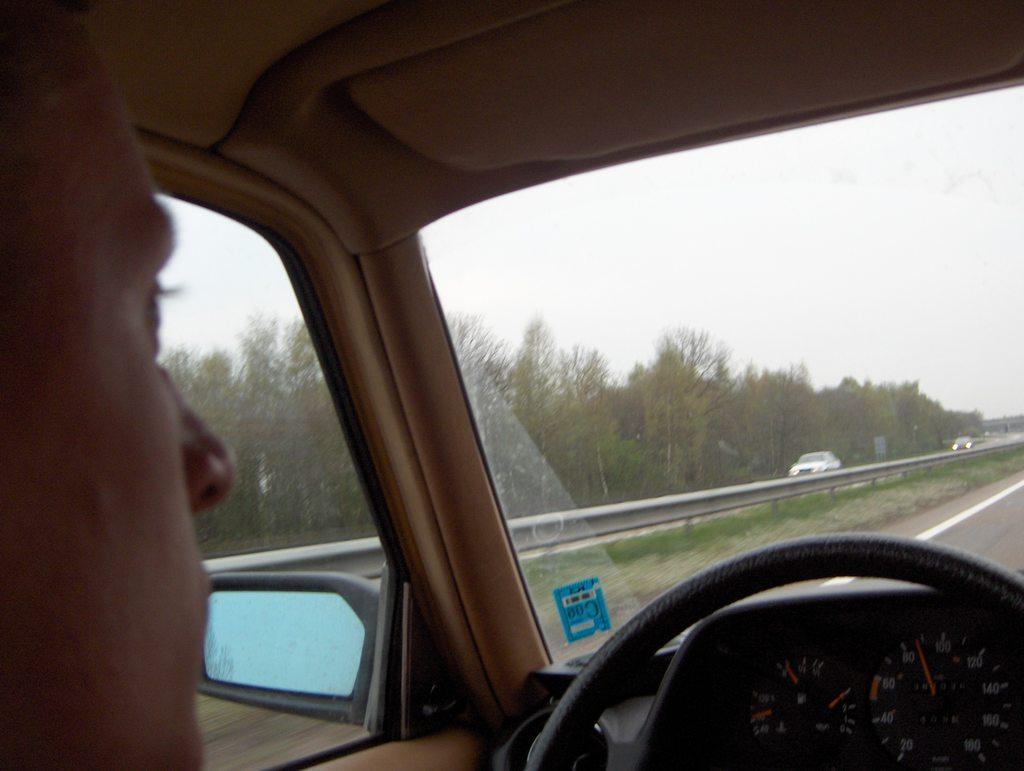How would you summarize this image in a sentence or two? This image consists of a person driving a car. In the front, we can see a road along with trees. In the middle, there is a metal railing along with the cars. 